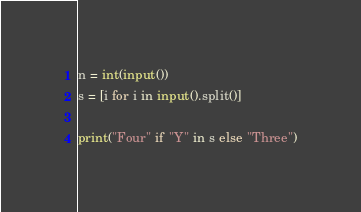<code> <loc_0><loc_0><loc_500><loc_500><_Python_>n = int(input())
s = [i for i in input().split()]

print("Four" if "Y" in s else "Three")</code> 